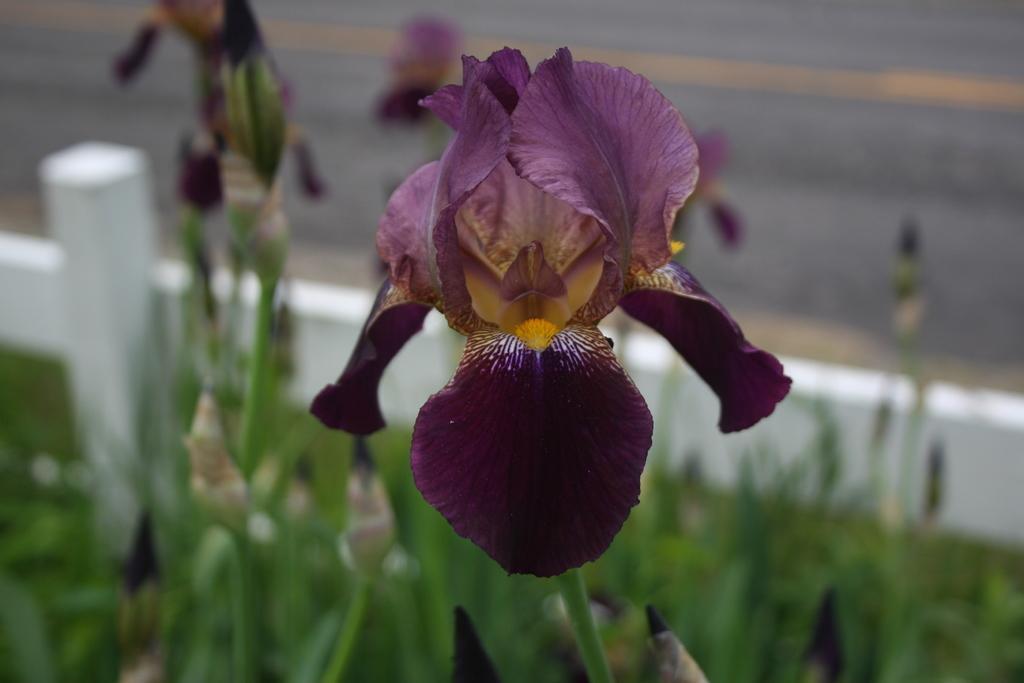Describe this image in one or two sentences. In this image there is a flower in the middle which is in violet color. At the bottom there are plants. In the background there is a road. There is a fence beside the plants. On the left side there is a wooden pole beside the fence. 